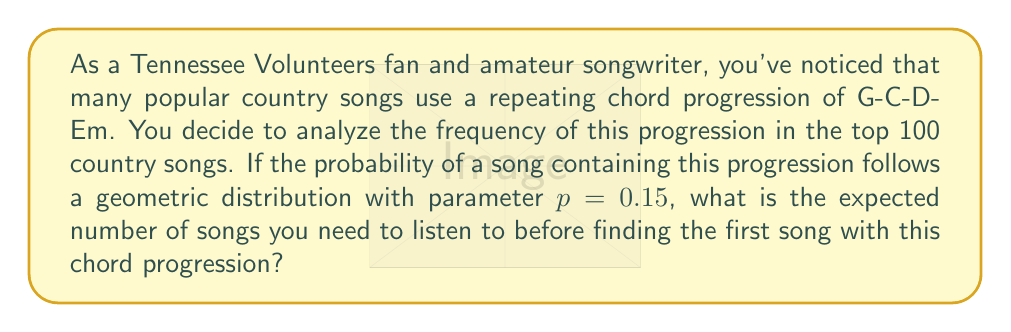Could you help me with this problem? To solve this problem, we need to understand the geometric distribution and its expected value formula.

1) The geometric distribution models the number of trials needed to achieve the first success in a series of independent Bernoulli trials.

2) In this case, each song we listen to is a trial, and finding a song with the G-C-D-Em progression is considered a success.

3) The probability of success (finding a song with this progression) is $p = 0.15$.

4) The expected value (mean) of a geometric distribution is given by the formula:

   $$E(X) = \frac{1}{p}$$

   Where $X$ is the random variable representing the number of trials until the first success, and $p$ is the probability of success on each trial.

5) Substituting our value of $p$:

   $$E(X) = \frac{1}{0.15}$$

6) Calculating:

   $$E(X) = \frac{100}{15} = \frac{20}{3} \approx 6.67$$

This means, on average, you would need to listen to about 6.67 songs before finding one with the G-C-D-Em chord progression.
Answer: $\frac{20}{3}$ or approximately 6.67 songs 